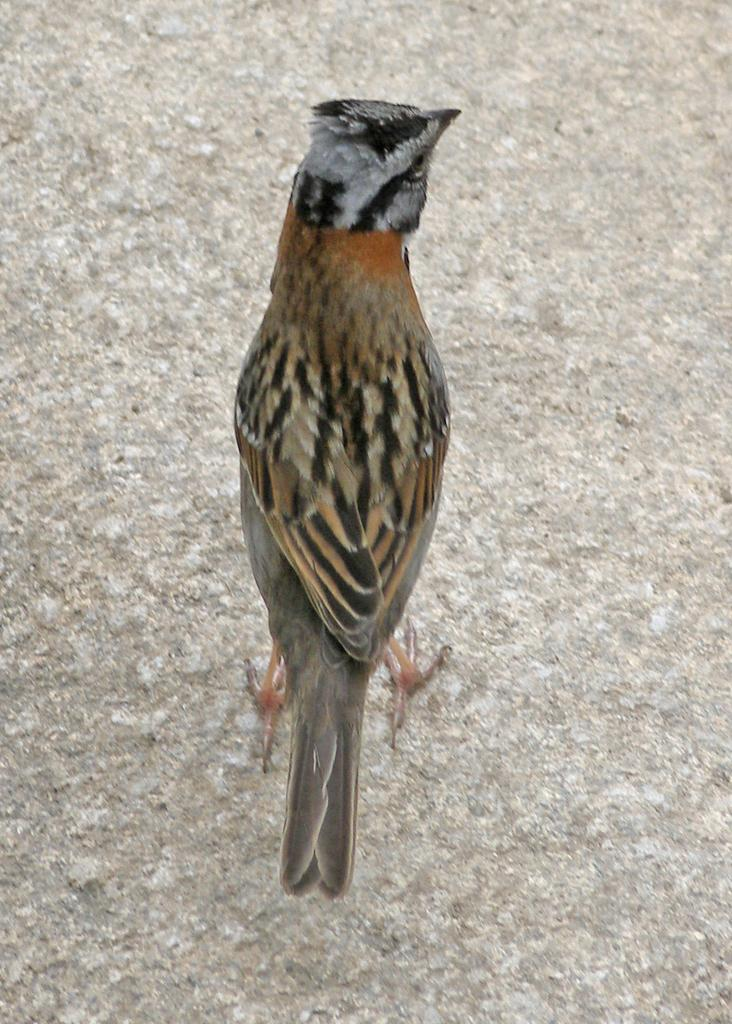What is the main subject of the image? There is a bird in the center of the image. Can you describe the bird in the image? Unfortunately, the image does not provide enough detail to describe the bird. What is the bird's position in the image? The bird is in the center of the image. What type of support can be seen holding up the beef in the image? There is no beef or support present in the image; it only features a bird. Can you tell me how many owls are visible in the image? There are no owls present in the image; it only features a bird. 